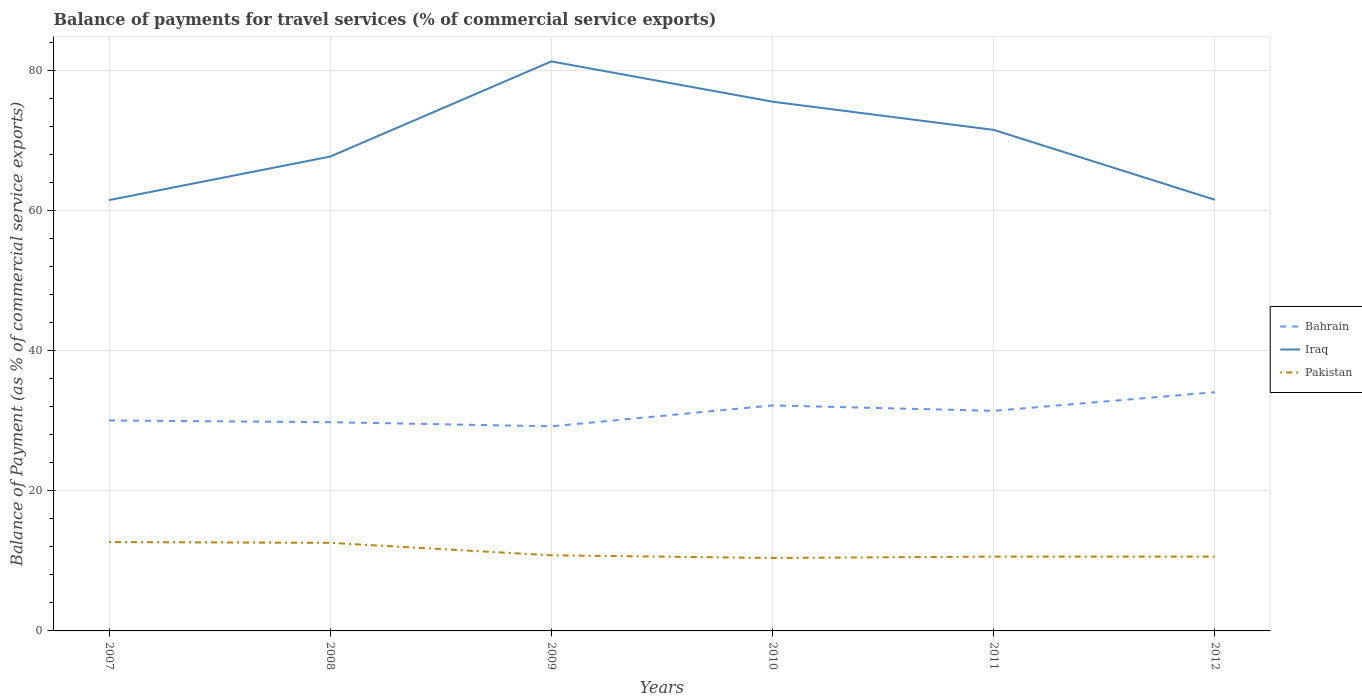How many different coloured lines are there?
Ensure brevity in your answer.  3. Does the line corresponding to Pakistan intersect with the line corresponding to Bahrain?
Your answer should be very brief. No. Is the number of lines equal to the number of legend labels?
Make the answer very short. Yes. Across all years, what is the maximum balance of payments for travel services in Pakistan?
Your answer should be very brief. 10.41. In which year was the balance of payments for travel services in Iraq maximum?
Your answer should be very brief. 2007. What is the total balance of payments for travel services in Bahrain in the graph?
Offer a terse response. -4.87. What is the difference between the highest and the second highest balance of payments for travel services in Pakistan?
Ensure brevity in your answer.  2.27. What is the difference between the highest and the lowest balance of payments for travel services in Pakistan?
Ensure brevity in your answer.  2. Is the balance of payments for travel services in Iraq strictly greater than the balance of payments for travel services in Bahrain over the years?
Make the answer very short. No. How many lines are there?
Make the answer very short. 3. What is the difference between two consecutive major ticks on the Y-axis?
Give a very brief answer. 20. Where does the legend appear in the graph?
Your answer should be compact. Center right. How are the legend labels stacked?
Provide a succinct answer. Vertical. What is the title of the graph?
Offer a very short reply. Balance of payments for travel services (% of commercial service exports). Does "Kyrgyz Republic" appear as one of the legend labels in the graph?
Provide a short and direct response. No. What is the label or title of the X-axis?
Keep it short and to the point. Years. What is the label or title of the Y-axis?
Provide a succinct answer. Balance of Payment (as % of commercial service exports). What is the Balance of Payment (as % of commercial service exports) of Bahrain in 2007?
Make the answer very short. 30.02. What is the Balance of Payment (as % of commercial service exports) of Iraq in 2007?
Your answer should be very brief. 61.45. What is the Balance of Payment (as % of commercial service exports) in Pakistan in 2007?
Make the answer very short. 12.67. What is the Balance of Payment (as % of commercial service exports) in Bahrain in 2008?
Make the answer very short. 29.78. What is the Balance of Payment (as % of commercial service exports) in Iraq in 2008?
Your answer should be very brief. 67.66. What is the Balance of Payment (as % of commercial service exports) in Pakistan in 2008?
Your answer should be very brief. 12.56. What is the Balance of Payment (as % of commercial service exports) in Bahrain in 2009?
Your answer should be compact. 29.18. What is the Balance of Payment (as % of commercial service exports) in Iraq in 2009?
Provide a succinct answer. 81.24. What is the Balance of Payment (as % of commercial service exports) of Pakistan in 2009?
Keep it short and to the point. 10.79. What is the Balance of Payment (as % of commercial service exports) in Bahrain in 2010?
Your answer should be compact. 32.17. What is the Balance of Payment (as % of commercial service exports) of Iraq in 2010?
Offer a terse response. 75.49. What is the Balance of Payment (as % of commercial service exports) of Pakistan in 2010?
Your response must be concise. 10.41. What is the Balance of Payment (as % of commercial service exports) in Bahrain in 2011?
Your response must be concise. 31.39. What is the Balance of Payment (as % of commercial service exports) of Iraq in 2011?
Make the answer very short. 71.47. What is the Balance of Payment (as % of commercial service exports) in Pakistan in 2011?
Your answer should be very brief. 10.6. What is the Balance of Payment (as % of commercial service exports) in Bahrain in 2012?
Offer a very short reply. 34.05. What is the Balance of Payment (as % of commercial service exports) in Iraq in 2012?
Provide a succinct answer. 61.5. What is the Balance of Payment (as % of commercial service exports) of Pakistan in 2012?
Your answer should be very brief. 10.6. Across all years, what is the maximum Balance of Payment (as % of commercial service exports) in Bahrain?
Your answer should be compact. 34.05. Across all years, what is the maximum Balance of Payment (as % of commercial service exports) of Iraq?
Give a very brief answer. 81.24. Across all years, what is the maximum Balance of Payment (as % of commercial service exports) of Pakistan?
Your response must be concise. 12.67. Across all years, what is the minimum Balance of Payment (as % of commercial service exports) in Bahrain?
Provide a succinct answer. 29.18. Across all years, what is the minimum Balance of Payment (as % of commercial service exports) in Iraq?
Make the answer very short. 61.45. Across all years, what is the minimum Balance of Payment (as % of commercial service exports) of Pakistan?
Give a very brief answer. 10.41. What is the total Balance of Payment (as % of commercial service exports) of Bahrain in the graph?
Offer a terse response. 186.59. What is the total Balance of Payment (as % of commercial service exports) of Iraq in the graph?
Give a very brief answer. 418.81. What is the total Balance of Payment (as % of commercial service exports) of Pakistan in the graph?
Provide a succinct answer. 67.63. What is the difference between the Balance of Payment (as % of commercial service exports) in Bahrain in 2007 and that in 2008?
Give a very brief answer. 0.25. What is the difference between the Balance of Payment (as % of commercial service exports) in Iraq in 2007 and that in 2008?
Your answer should be very brief. -6.21. What is the difference between the Balance of Payment (as % of commercial service exports) in Pakistan in 2007 and that in 2008?
Keep it short and to the point. 0.11. What is the difference between the Balance of Payment (as % of commercial service exports) in Bahrain in 2007 and that in 2009?
Offer a very short reply. 0.84. What is the difference between the Balance of Payment (as % of commercial service exports) in Iraq in 2007 and that in 2009?
Your response must be concise. -19.79. What is the difference between the Balance of Payment (as % of commercial service exports) of Pakistan in 2007 and that in 2009?
Your answer should be very brief. 1.89. What is the difference between the Balance of Payment (as % of commercial service exports) of Bahrain in 2007 and that in 2010?
Provide a succinct answer. -2.15. What is the difference between the Balance of Payment (as % of commercial service exports) of Iraq in 2007 and that in 2010?
Provide a succinct answer. -14.04. What is the difference between the Balance of Payment (as % of commercial service exports) of Pakistan in 2007 and that in 2010?
Make the answer very short. 2.27. What is the difference between the Balance of Payment (as % of commercial service exports) in Bahrain in 2007 and that in 2011?
Give a very brief answer. -1.37. What is the difference between the Balance of Payment (as % of commercial service exports) of Iraq in 2007 and that in 2011?
Make the answer very short. -10.02. What is the difference between the Balance of Payment (as % of commercial service exports) of Pakistan in 2007 and that in 2011?
Ensure brevity in your answer.  2.08. What is the difference between the Balance of Payment (as % of commercial service exports) of Bahrain in 2007 and that in 2012?
Offer a terse response. -4.03. What is the difference between the Balance of Payment (as % of commercial service exports) in Iraq in 2007 and that in 2012?
Offer a terse response. -0.05. What is the difference between the Balance of Payment (as % of commercial service exports) in Pakistan in 2007 and that in 2012?
Your answer should be very brief. 2.08. What is the difference between the Balance of Payment (as % of commercial service exports) in Bahrain in 2008 and that in 2009?
Provide a short and direct response. 0.59. What is the difference between the Balance of Payment (as % of commercial service exports) of Iraq in 2008 and that in 2009?
Your answer should be very brief. -13.57. What is the difference between the Balance of Payment (as % of commercial service exports) of Pakistan in 2008 and that in 2009?
Provide a succinct answer. 1.78. What is the difference between the Balance of Payment (as % of commercial service exports) in Bahrain in 2008 and that in 2010?
Ensure brevity in your answer.  -2.39. What is the difference between the Balance of Payment (as % of commercial service exports) of Iraq in 2008 and that in 2010?
Your answer should be very brief. -7.83. What is the difference between the Balance of Payment (as % of commercial service exports) of Pakistan in 2008 and that in 2010?
Give a very brief answer. 2.16. What is the difference between the Balance of Payment (as % of commercial service exports) of Bahrain in 2008 and that in 2011?
Offer a very short reply. -1.61. What is the difference between the Balance of Payment (as % of commercial service exports) of Iraq in 2008 and that in 2011?
Keep it short and to the point. -3.81. What is the difference between the Balance of Payment (as % of commercial service exports) in Pakistan in 2008 and that in 2011?
Provide a succinct answer. 1.97. What is the difference between the Balance of Payment (as % of commercial service exports) of Bahrain in 2008 and that in 2012?
Ensure brevity in your answer.  -4.28. What is the difference between the Balance of Payment (as % of commercial service exports) in Iraq in 2008 and that in 2012?
Make the answer very short. 6.16. What is the difference between the Balance of Payment (as % of commercial service exports) of Pakistan in 2008 and that in 2012?
Your answer should be very brief. 1.97. What is the difference between the Balance of Payment (as % of commercial service exports) of Bahrain in 2009 and that in 2010?
Provide a short and direct response. -2.98. What is the difference between the Balance of Payment (as % of commercial service exports) of Iraq in 2009 and that in 2010?
Your answer should be compact. 5.75. What is the difference between the Balance of Payment (as % of commercial service exports) of Pakistan in 2009 and that in 2010?
Your answer should be compact. 0.38. What is the difference between the Balance of Payment (as % of commercial service exports) in Bahrain in 2009 and that in 2011?
Ensure brevity in your answer.  -2.21. What is the difference between the Balance of Payment (as % of commercial service exports) in Iraq in 2009 and that in 2011?
Offer a terse response. 9.77. What is the difference between the Balance of Payment (as % of commercial service exports) of Pakistan in 2009 and that in 2011?
Provide a succinct answer. 0.19. What is the difference between the Balance of Payment (as % of commercial service exports) in Bahrain in 2009 and that in 2012?
Your answer should be compact. -4.87. What is the difference between the Balance of Payment (as % of commercial service exports) in Iraq in 2009 and that in 2012?
Offer a very short reply. 19.74. What is the difference between the Balance of Payment (as % of commercial service exports) in Pakistan in 2009 and that in 2012?
Provide a short and direct response. 0.19. What is the difference between the Balance of Payment (as % of commercial service exports) of Bahrain in 2010 and that in 2011?
Offer a very short reply. 0.78. What is the difference between the Balance of Payment (as % of commercial service exports) of Iraq in 2010 and that in 2011?
Your response must be concise. 4.02. What is the difference between the Balance of Payment (as % of commercial service exports) of Pakistan in 2010 and that in 2011?
Provide a succinct answer. -0.19. What is the difference between the Balance of Payment (as % of commercial service exports) in Bahrain in 2010 and that in 2012?
Give a very brief answer. -1.88. What is the difference between the Balance of Payment (as % of commercial service exports) in Iraq in 2010 and that in 2012?
Provide a succinct answer. 13.99. What is the difference between the Balance of Payment (as % of commercial service exports) in Pakistan in 2010 and that in 2012?
Keep it short and to the point. -0.19. What is the difference between the Balance of Payment (as % of commercial service exports) in Bahrain in 2011 and that in 2012?
Your answer should be very brief. -2.66. What is the difference between the Balance of Payment (as % of commercial service exports) in Iraq in 2011 and that in 2012?
Your answer should be compact. 9.97. What is the difference between the Balance of Payment (as % of commercial service exports) in Pakistan in 2011 and that in 2012?
Your response must be concise. 0. What is the difference between the Balance of Payment (as % of commercial service exports) in Bahrain in 2007 and the Balance of Payment (as % of commercial service exports) in Iraq in 2008?
Ensure brevity in your answer.  -37.64. What is the difference between the Balance of Payment (as % of commercial service exports) in Bahrain in 2007 and the Balance of Payment (as % of commercial service exports) in Pakistan in 2008?
Your answer should be compact. 17.46. What is the difference between the Balance of Payment (as % of commercial service exports) of Iraq in 2007 and the Balance of Payment (as % of commercial service exports) of Pakistan in 2008?
Make the answer very short. 48.89. What is the difference between the Balance of Payment (as % of commercial service exports) of Bahrain in 2007 and the Balance of Payment (as % of commercial service exports) of Iraq in 2009?
Make the answer very short. -51.22. What is the difference between the Balance of Payment (as % of commercial service exports) of Bahrain in 2007 and the Balance of Payment (as % of commercial service exports) of Pakistan in 2009?
Your answer should be very brief. 19.24. What is the difference between the Balance of Payment (as % of commercial service exports) in Iraq in 2007 and the Balance of Payment (as % of commercial service exports) in Pakistan in 2009?
Your answer should be very brief. 50.67. What is the difference between the Balance of Payment (as % of commercial service exports) in Bahrain in 2007 and the Balance of Payment (as % of commercial service exports) in Iraq in 2010?
Keep it short and to the point. -45.47. What is the difference between the Balance of Payment (as % of commercial service exports) in Bahrain in 2007 and the Balance of Payment (as % of commercial service exports) in Pakistan in 2010?
Make the answer very short. 19.62. What is the difference between the Balance of Payment (as % of commercial service exports) of Iraq in 2007 and the Balance of Payment (as % of commercial service exports) of Pakistan in 2010?
Provide a succinct answer. 51.05. What is the difference between the Balance of Payment (as % of commercial service exports) of Bahrain in 2007 and the Balance of Payment (as % of commercial service exports) of Iraq in 2011?
Keep it short and to the point. -41.45. What is the difference between the Balance of Payment (as % of commercial service exports) in Bahrain in 2007 and the Balance of Payment (as % of commercial service exports) in Pakistan in 2011?
Your answer should be very brief. 19.42. What is the difference between the Balance of Payment (as % of commercial service exports) in Iraq in 2007 and the Balance of Payment (as % of commercial service exports) in Pakistan in 2011?
Your answer should be compact. 50.85. What is the difference between the Balance of Payment (as % of commercial service exports) in Bahrain in 2007 and the Balance of Payment (as % of commercial service exports) in Iraq in 2012?
Provide a succinct answer. -31.48. What is the difference between the Balance of Payment (as % of commercial service exports) of Bahrain in 2007 and the Balance of Payment (as % of commercial service exports) of Pakistan in 2012?
Give a very brief answer. 19.42. What is the difference between the Balance of Payment (as % of commercial service exports) of Iraq in 2007 and the Balance of Payment (as % of commercial service exports) of Pakistan in 2012?
Your response must be concise. 50.85. What is the difference between the Balance of Payment (as % of commercial service exports) of Bahrain in 2008 and the Balance of Payment (as % of commercial service exports) of Iraq in 2009?
Your answer should be compact. -51.46. What is the difference between the Balance of Payment (as % of commercial service exports) in Bahrain in 2008 and the Balance of Payment (as % of commercial service exports) in Pakistan in 2009?
Keep it short and to the point. 18.99. What is the difference between the Balance of Payment (as % of commercial service exports) of Iraq in 2008 and the Balance of Payment (as % of commercial service exports) of Pakistan in 2009?
Your response must be concise. 56.88. What is the difference between the Balance of Payment (as % of commercial service exports) in Bahrain in 2008 and the Balance of Payment (as % of commercial service exports) in Iraq in 2010?
Offer a very short reply. -45.71. What is the difference between the Balance of Payment (as % of commercial service exports) of Bahrain in 2008 and the Balance of Payment (as % of commercial service exports) of Pakistan in 2010?
Offer a very short reply. 19.37. What is the difference between the Balance of Payment (as % of commercial service exports) of Iraq in 2008 and the Balance of Payment (as % of commercial service exports) of Pakistan in 2010?
Offer a terse response. 57.26. What is the difference between the Balance of Payment (as % of commercial service exports) of Bahrain in 2008 and the Balance of Payment (as % of commercial service exports) of Iraq in 2011?
Your answer should be very brief. -41.69. What is the difference between the Balance of Payment (as % of commercial service exports) of Bahrain in 2008 and the Balance of Payment (as % of commercial service exports) of Pakistan in 2011?
Keep it short and to the point. 19.18. What is the difference between the Balance of Payment (as % of commercial service exports) of Iraq in 2008 and the Balance of Payment (as % of commercial service exports) of Pakistan in 2011?
Your response must be concise. 57.06. What is the difference between the Balance of Payment (as % of commercial service exports) of Bahrain in 2008 and the Balance of Payment (as % of commercial service exports) of Iraq in 2012?
Keep it short and to the point. -31.72. What is the difference between the Balance of Payment (as % of commercial service exports) in Bahrain in 2008 and the Balance of Payment (as % of commercial service exports) in Pakistan in 2012?
Offer a terse response. 19.18. What is the difference between the Balance of Payment (as % of commercial service exports) of Iraq in 2008 and the Balance of Payment (as % of commercial service exports) of Pakistan in 2012?
Your response must be concise. 57.06. What is the difference between the Balance of Payment (as % of commercial service exports) in Bahrain in 2009 and the Balance of Payment (as % of commercial service exports) in Iraq in 2010?
Your answer should be compact. -46.31. What is the difference between the Balance of Payment (as % of commercial service exports) of Bahrain in 2009 and the Balance of Payment (as % of commercial service exports) of Pakistan in 2010?
Give a very brief answer. 18.78. What is the difference between the Balance of Payment (as % of commercial service exports) in Iraq in 2009 and the Balance of Payment (as % of commercial service exports) in Pakistan in 2010?
Keep it short and to the point. 70.83. What is the difference between the Balance of Payment (as % of commercial service exports) of Bahrain in 2009 and the Balance of Payment (as % of commercial service exports) of Iraq in 2011?
Provide a succinct answer. -42.28. What is the difference between the Balance of Payment (as % of commercial service exports) of Bahrain in 2009 and the Balance of Payment (as % of commercial service exports) of Pakistan in 2011?
Offer a very short reply. 18.59. What is the difference between the Balance of Payment (as % of commercial service exports) of Iraq in 2009 and the Balance of Payment (as % of commercial service exports) of Pakistan in 2011?
Ensure brevity in your answer.  70.64. What is the difference between the Balance of Payment (as % of commercial service exports) in Bahrain in 2009 and the Balance of Payment (as % of commercial service exports) in Iraq in 2012?
Provide a succinct answer. -32.31. What is the difference between the Balance of Payment (as % of commercial service exports) of Bahrain in 2009 and the Balance of Payment (as % of commercial service exports) of Pakistan in 2012?
Ensure brevity in your answer.  18.59. What is the difference between the Balance of Payment (as % of commercial service exports) of Iraq in 2009 and the Balance of Payment (as % of commercial service exports) of Pakistan in 2012?
Your answer should be very brief. 70.64. What is the difference between the Balance of Payment (as % of commercial service exports) in Bahrain in 2010 and the Balance of Payment (as % of commercial service exports) in Iraq in 2011?
Keep it short and to the point. -39.3. What is the difference between the Balance of Payment (as % of commercial service exports) of Bahrain in 2010 and the Balance of Payment (as % of commercial service exports) of Pakistan in 2011?
Give a very brief answer. 21.57. What is the difference between the Balance of Payment (as % of commercial service exports) in Iraq in 2010 and the Balance of Payment (as % of commercial service exports) in Pakistan in 2011?
Ensure brevity in your answer.  64.89. What is the difference between the Balance of Payment (as % of commercial service exports) of Bahrain in 2010 and the Balance of Payment (as % of commercial service exports) of Iraq in 2012?
Your answer should be compact. -29.33. What is the difference between the Balance of Payment (as % of commercial service exports) of Bahrain in 2010 and the Balance of Payment (as % of commercial service exports) of Pakistan in 2012?
Ensure brevity in your answer.  21.57. What is the difference between the Balance of Payment (as % of commercial service exports) of Iraq in 2010 and the Balance of Payment (as % of commercial service exports) of Pakistan in 2012?
Offer a very short reply. 64.89. What is the difference between the Balance of Payment (as % of commercial service exports) of Bahrain in 2011 and the Balance of Payment (as % of commercial service exports) of Iraq in 2012?
Offer a terse response. -30.11. What is the difference between the Balance of Payment (as % of commercial service exports) of Bahrain in 2011 and the Balance of Payment (as % of commercial service exports) of Pakistan in 2012?
Provide a succinct answer. 20.79. What is the difference between the Balance of Payment (as % of commercial service exports) of Iraq in 2011 and the Balance of Payment (as % of commercial service exports) of Pakistan in 2012?
Provide a succinct answer. 60.87. What is the average Balance of Payment (as % of commercial service exports) in Bahrain per year?
Provide a succinct answer. 31.1. What is the average Balance of Payment (as % of commercial service exports) in Iraq per year?
Your answer should be very brief. 69.8. What is the average Balance of Payment (as % of commercial service exports) of Pakistan per year?
Provide a short and direct response. 11.27. In the year 2007, what is the difference between the Balance of Payment (as % of commercial service exports) of Bahrain and Balance of Payment (as % of commercial service exports) of Iraq?
Make the answer very short. -31.43. In the year 2007, what is the difference between the Balance of Payment (as % of commercial service exports) of Bahrain and Balance of Payment (as % of commercial service exports) of Pakistan?
Provide a short and direct response. 17.35. In the year 2007, what is the difference between the Balance of Payment (as % of commercial service exports) in Iraq and Balance of Payment (as % of commercial service exports) in Pakistan?
Make the answer very short. 48.78. In the year 2008, what is the difference between the Balance of Payment (as % of commercial service exports) in Bahrain and Balance of Payment (as % of commercial service exports) in Iraq?
Provide a short and direct response. -37.89. In the year 2008, what is the difference between the Balance of Payment (as % of commercial service exports) in Bahrain and Balance of Payment (as % of commercial service exports) in Pakistan?
Provide a succinct answer. 17.21. In the year 2008, what is the difference between the Balance of Payment (as % of commercial service exports) of Iraq and Balance of Payment (as % of commercial service exports) of Pakistan?
Provide a succinct answer. 55.1. In the year 2009, what is the difference between the Balance of Payment (as % of commercial service exports) of Bahrain and Balance of Payment (as % of commercial service exports) of Iraq?
Your answer should be compact. -52.05. In the year 2009, what is the difference between the Balance of Payment (as % of commercial service exports) in Bahrain and Balance of Payment (as % of commercial service exports) in Pakistan?
Your response must be concise. 18.4. In the year 2009, what is the difference between the Balance of Payment (as % of commercial service exports) in Iraq and Balance of Payment (as % of commercial service exports) in Pakistan?
Offer a very short reply. 70.45. In the year 2010, what is the difference between the Balance of Payment (as % of commercial service exports) of Bahrain and Balance of Payment (as % of commercial service exports) of Iraq?
Provide a succinct answer. -43.32. In the year 2010, what is the difference between the Balance of Payment (as % of commercial service exports) in Bahrain and Balance of Payment (as % of commercial service exports) in Pakistan?
Provide a short and direct response. 21.76. In the year 2010, what is the difference between the Balance of Payment (as % of commercial service exports) in Iraq and Balance of Payment (as % of commercial service exports) in Pakistan?
Give a very brief answer. 65.08. In the year 2011, what is the difference between the Balance of Payment (as % of commercial service exports) of Bahrain and Balance of Payment (as % of commercial service exports) of Iraq?
Your response must be concise. -40.08. In the year 2011, what is the difference between the Balance of Payment (as % of commercial service exports) of Bahrain and Balance of Payment (as % of commercial service exports) of Pakistan?
Your answer should be very brief. 20.79. In the year 2011, what is the difference between the Balance of Payment (as % of commercial service exports) of Iraq and Balance of Payment (as % of commercial service exports) of Pakistan?
Offer a very short reply. 60.87. In the year 2012, what is the difference between the Balance of Payment (as % of commercial service exports) in Bahrain and Balance of Payment (as % of commercial service exports) in Iraq?
Offer a terse response. -27.45. In the year 2012, what is the difference between the Balance of Payment (as % of commercial service exports) in Bahrain and Balance of Payment (as % of commercial service exports) in Pakistan?
Keep it short and to the point. 23.45. In the year 2012, what is the difference between the Balance of Payment (as % of commercial service exports) of Iraq and Balance of Payment (as % of commercial service exports) of Pakistan?
Offer a very short reply. 50.9. What is the ratio of the Balance of Payment (as % of commercial service exports) in Bahrain in 2007 to that in 2008?
Offer a terse response. 1.01. What is the ratio of the Balance of Payment (as % of commercial service exports) of Iraq in 2007 to that in 2008?
Make the answer very short. 0.91. What is the ratio of the Balance of Payment (as % of commercial service exports) of Pakistan in 2007 to that in 2008?
Provide a succinct answer. 1.01. What is the ratio of the Balance of Payment (as % of commercial service exports) of Bahrain in 2007 to that in 2009?
Keep it short and to the point. 1.03. What is the ratio of the Balance of Payment (as % of commercial service exports) of Iraq in 2007 to that in 2009?
Your response must be concise. 0.76. What is the ratio of the Balance of Payment (as % of commercial service exports) in Pakistan in 2007 to that in 2009?
Provide a succinct answer. 1.18. What is the ratio of the Balance of Payment (as % of commercial service exports) in Bahrain in 2007 to that in 2010?
Give a very brief answer. 0.93. What is the ratio of the Balance of Payment (as % of commercial service exports) in Iraq in 2007 to that in 2010?
Your answer should be compact. 0.81. What is the ratio of the Balance of Payment (as % of commercial service exports) of Pakistan in 2007 to that in 2010?
Ensure brevity in your answer.  1.22. What is the ratio of the Balance of Payment (as % of commercial service exports) in Bahrain in 2007 to that in 2011?
Offer a very short reply. 0.96. What is the ratio of the Balance of Payment (as % of commercial service exports) in Iraq in 2007 to that in 2011?
Offer a terse response. 0.86. What is the ratio of the Balance of Payment (as % of commercial service exports) in Pakistan in 2007 to that in 2011?
Your answer should be compact. 1.2. What is the ratio of the Balance of Payment (as % of commercial service exports) in Bahrain in 2007 to that in 2012?
Provide a short and direct response. 0.88. What is the ratio of the Balance of Payment (as % of commercial service exports) in Pakistan in 2007 to that in 2012?
Your response must be concise. 1.2. What is the ratio of the Balance of Payment (as % of commercial service exports) in Bahrain in 2008 to that in 2009?
Ensure brevity in your answer.  1.02. What is the ratio of the Balance of Payment (as % of commercial service exports) of Iraq in 2008 to that in 2009?
Make the answer very short. 0.83. What is the ratio of the Balance of Payment (as % of commercial service exports) of Pakistan in 2008 to that in 2009?
Keep it short and to the point. 1.17. What is the ratio of the Balance of Payment (as % of commercial service exports) in Bahrain in 2008 to that in 2010?
Provide a succinct answer. 0.93. What is the ratio of the Balance of Payment (as % of commercial service exports) in Iraq in 2008 to that in 2010?
Your answer should be very brief. 0.9. What is the ratio of the Balance of Payment (as % of commercial service exports) of Pakistan in 2008 to that in 2010?
Offer a very short reply. 1.21. What is the ratio of the Balance of Payment (as % of commercial service exports) in Bahrain in 2008 to that in 2011?
Offer a terse response. 0.95. What is the ratio of the Balance of Payment (as % of commercial service exports) of Iraq in 2008 to that in 2011?
Your answer should be compact. 0.95. What is the ratio of the Balance of Payment (as % of commercial service exports) of Pakistan in 2008 to that in 2011?
Your answer should be very brief. 1.19. What is the ratio of the Balance of Payment (as % of commercial service exports) of Bahrain in 2008 to that in 2012?
Your response must be concise. 0.87. What is the ratio of the Balance of Payment (as % of commercial service exports) of Iraq in 2008 to that in 2012?
Your answer should be compact. 1.1. What is the ratio of the Balance of Payment (as % of commercial service exports) of Pakistan in 2008 to that in 2012?
Ensure brevity in your answer.  1.19. What is the ratio of the Balance of Payment (as % of commercial service exports) in Bahrain in 2009 to that in 2010?
Provide a short and direct response. 0.91. What is the ratio of the Balance of Payment (as % of commercial service exports) of Iraq in 2009 to that in 2010?
Ensure brevity in your answer.  1.08. What is the ratio of the Balance of Payment (as % of commercial service exports) in Pakistan in 2009 to that in 2010?
Your answer should be very brief. 1.04. What is the ratio of the Balance of Payment (as % of commercial service exports) of Bahrain in 2009 to that in 2011?
Offer a terse response. 0.93. What is the ratio of the Balance of Payment (as % of commercial service exports) of Iraq in 2009 to that in 2011?
Offer a very short reply. 1.14. What is the ratio of the Balance of Payment (as % of commercial service exports) of Pakistan in 2009 to that in 2011?
Make the answer very short. 1.02. What is the ratio of the Balance of Payment (as % of commercial service exports) in Iraq in 2009 to that in 2012?
Your response must be concise. 1.32. What is the ratio of the Balance of Payment (as % of commercial service exports) of Pakistan in 2009 to that in 2012?
Your response must be concise. 1.02. What is the ratio of the Balance of Payment (as % of commercial service exports) in Bahrain in 2010 to that in 2011?
Your response must be concise. 1.02. What is the ratio of the Balance of Payment (as % of commercial service exports) of Iraq in 2010 to that in 2011?
Ensure brevity in your answer.  1.06. What is the ratio of the Balance of Payment (as % of commercial service exports) of Pakistan in 2010 to that in 2011?
Give a very brief answer. 0.98. What is the ratio of the Balance of Payment (as % of commercial service exports) in Bahrain in 2010 to that in 2012?
Ensure brevity in your answer.  0.94. What is the ratio of the Balance of Payment (as % of commercial service exports) of Iraq in 2010 to that in 2012?
Keep it short and to the point. 1.23. What is the ratio of the Balance of Payment (as % of commercial service exports) of Pakistan in 2010 to that in 2012?
Provide a short and direct response. 0.98. What is the ratio of the Balance of Payment (as % of commercial service exports) in Bahrain in 2011 to that in 2012?
Your answer should be compact. 0.92. What is the ratio of the Balance of Payment (as % of commercial service exports) of Iraq in 2011 to that in 2012?
Ensure brevity in your answer.  1.16. What is the ratio of the Balance of Payment (as % of commercial service exports) in Pakistan in 2011 to that in 2012?
Your response must be concise. 1. What is the difference between the highest and the second highest Balance of Payment (as % of commercial service exports) of Bahrain?
Give a very brief answer. 1.88. What is the difference between the highest and the second highest Balance of Payment (as % of commercial service exports) in Iraq?
Ensure brevity in your answer.  5.75. What is the difference between the highest and the second highest Balance of Payment (as % of commercial service exports) in Pakistan?
Keep it short and to the point. 0.11. What is the difference between the highest and the lowest Balance of Payment (as % of commercial service exports) of Bahrain?
Provide a short and direct response. 4.87. What is the difference between the highest and the lowest Balance of Payment (as % of commercial service exports) of Iraq?
Keep it short and to the point. 19.79. What is the difference between the highest and the lowest Balance of Payment (as % of commercial service exports) in Pakistan?
Your answer should be very brief. 2.27. 